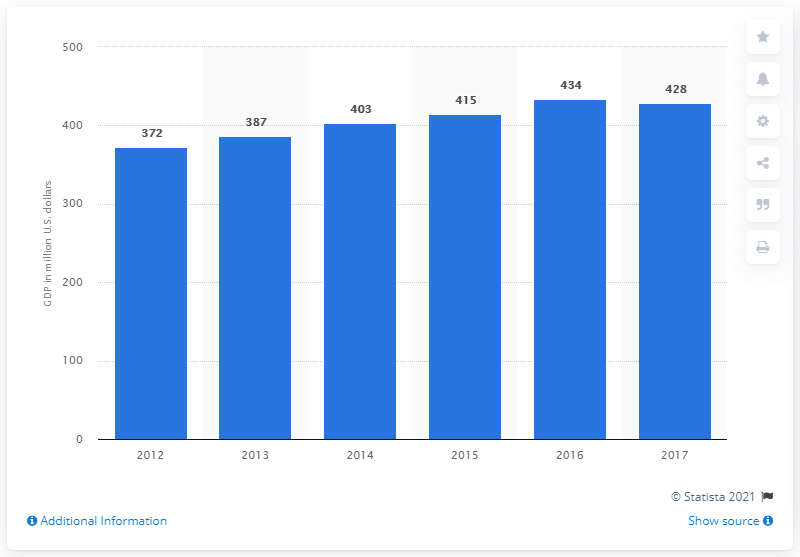Give some essential details in this illustration. According to the information provided, Bonaire's Gross Domestic Product (GDP) decreased slightly in the year 2017. In the year 2012, the Gross Domestic Product (GDP) of Bonaire was valued at approximately 372. The Gross Domestic Product (GDP) of Bonaire in 2016 was 434. Bonaire's Gross Domestic Product, or GDP, was 428 in 2017. 